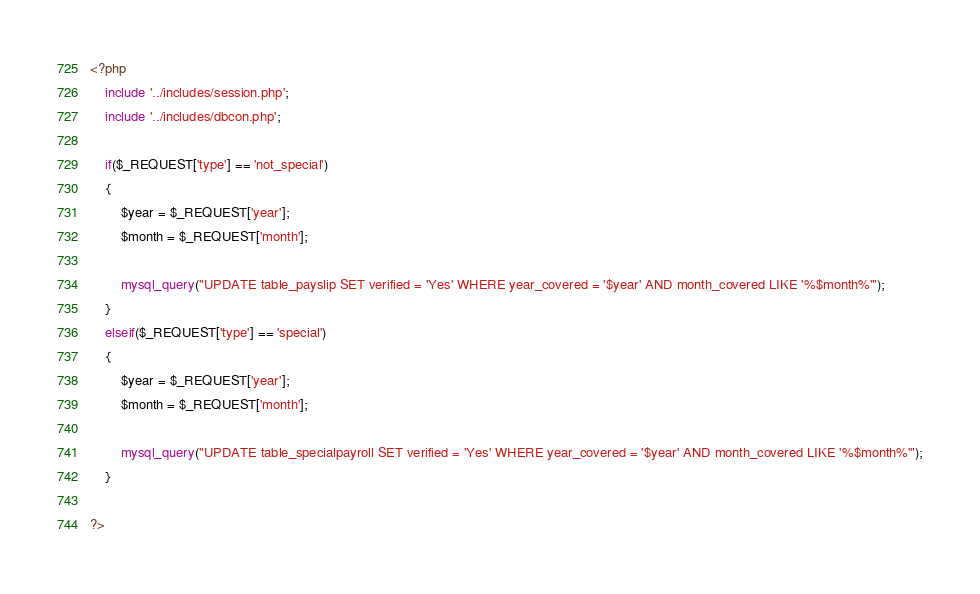<code> <loc_0><loc_0><loc_500><loc_500><_PHP_><?php
	include '../includes/session.php';
	include '../includes/dbcon.php';

	if($_REQUEST['type'] == 'not_special')
	{
		$year = $_REQUEST['year'];
	    $month = $_REQUEST['month'];
	  	
	  	mysql_query("UPDATE table_payslip SET verified = 'Yes' WHERE year_covered = '$year' AND month_covered LIKE '%$month%'");
	}
	elseif($_REQUEST['type'] == 'special')
	{
		$year = $_REQUEST['year'];
	    $month = $_REQUEST['month'];
	  	
	  	mysql_query("UPDATE table_specialpayroll SET verified = 'Yes' WHERE year_covered = '$year' AND month_covered LIKE '%$month%'");
	}

?></code> 